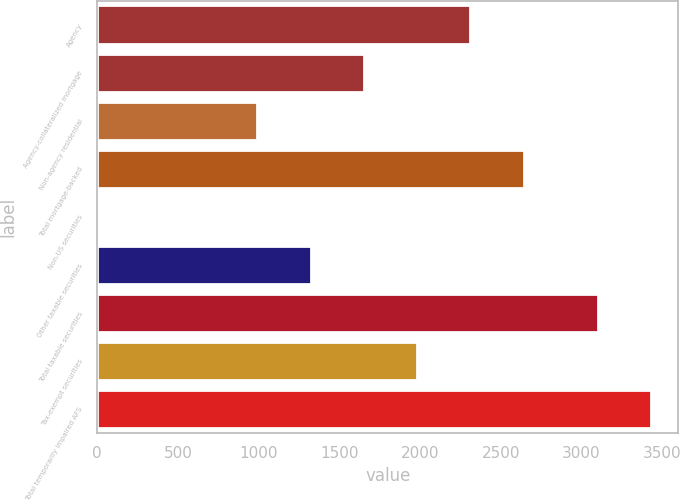Convert chart. <chart><loc_0><loc_0><loc_500><loc_500><bar_chart><fcel>Agency<fcel>Agency-collateralized mortgage<fcel>Non-agency residential<fcel>Total mortgage-backed<fcel>Non-US securities<fcel>Other taxable securities<fcel>Total taxable securities<fcel>Tax-exempt securities<fcel>Total temporarily impaired AFS<nl><fcel>2310.9<fcel>1651.5<fcel>992.1<fcel>2640.6<fcel>3<fcel>1321.8<fcel>3099<fcel>1981.2<fcel>3428.7<nl></chart> 